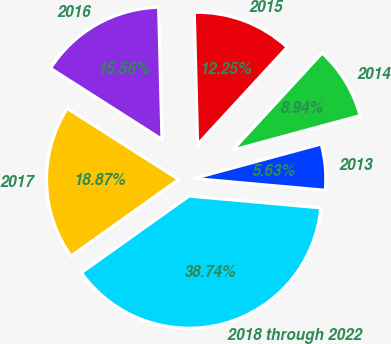<chart> <loc_0><loc_0><loc_500><loc_500><pie_chart><fcel>2013<fcel>2014<fcel>2015<fcel>2016<fcel>2017<fcel>2018 through 2022<nl><fcel>5.63%<fcel>8.94%<fcel>12.25%<fcel>15.56%<fcel>18.87%<fcel>38.73%<nl></chart> 